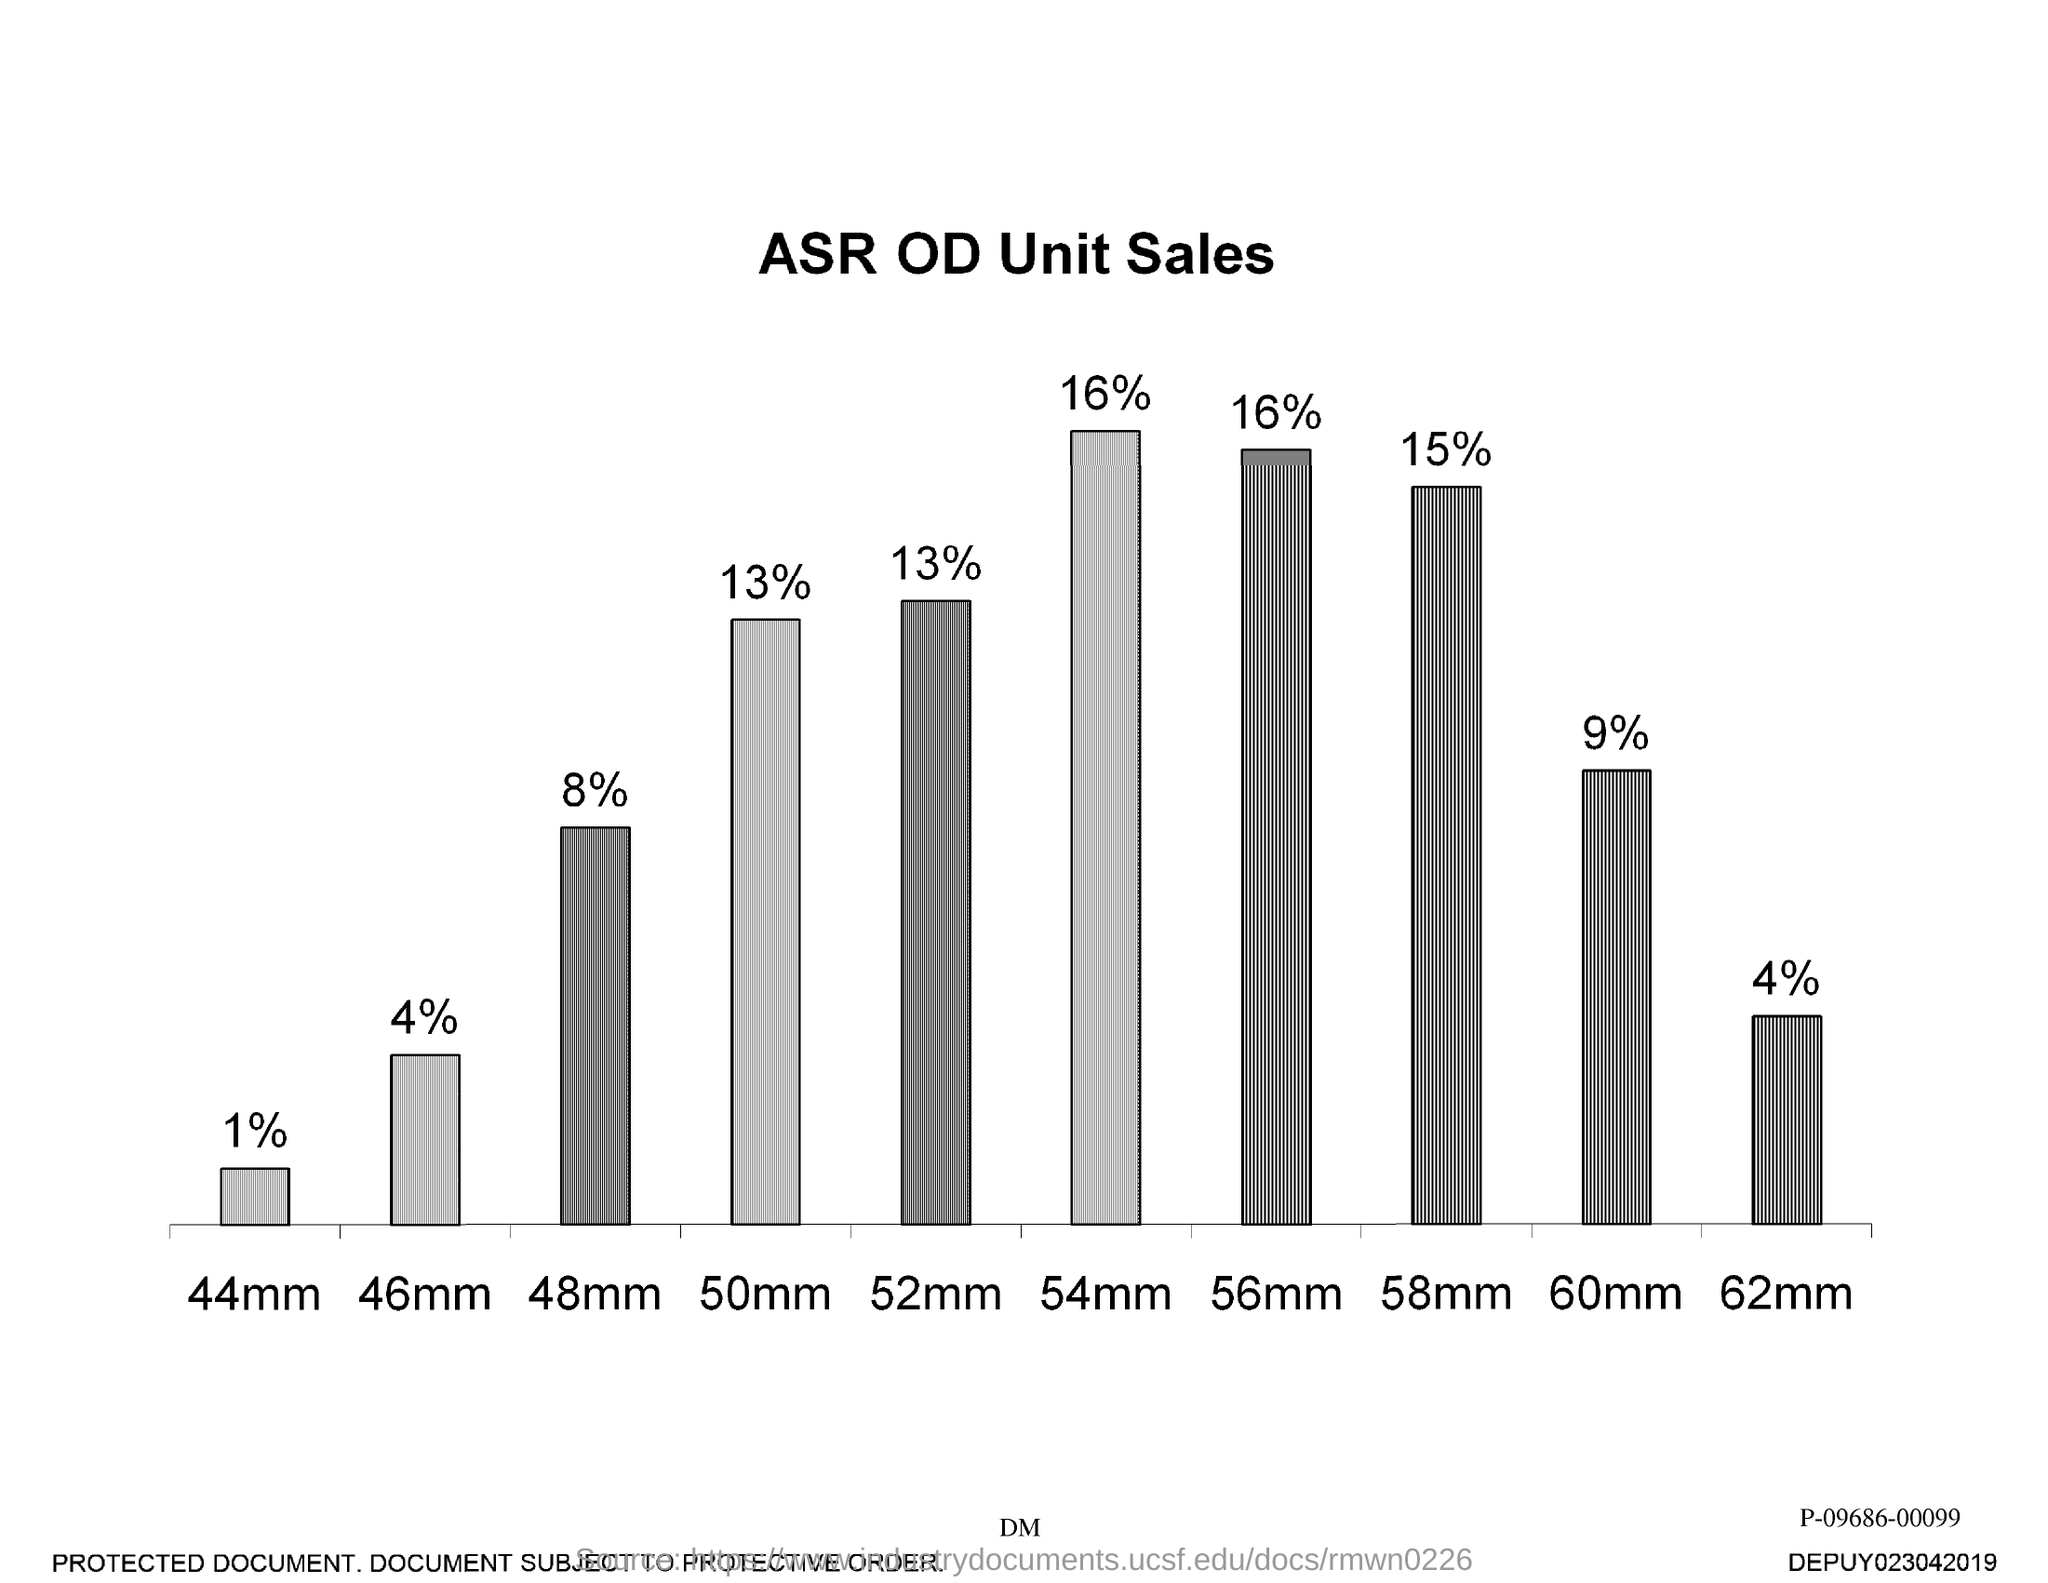What is the title of the graph given?
Ensure brevity in your answer.  ASR OD UNIT SALES. 